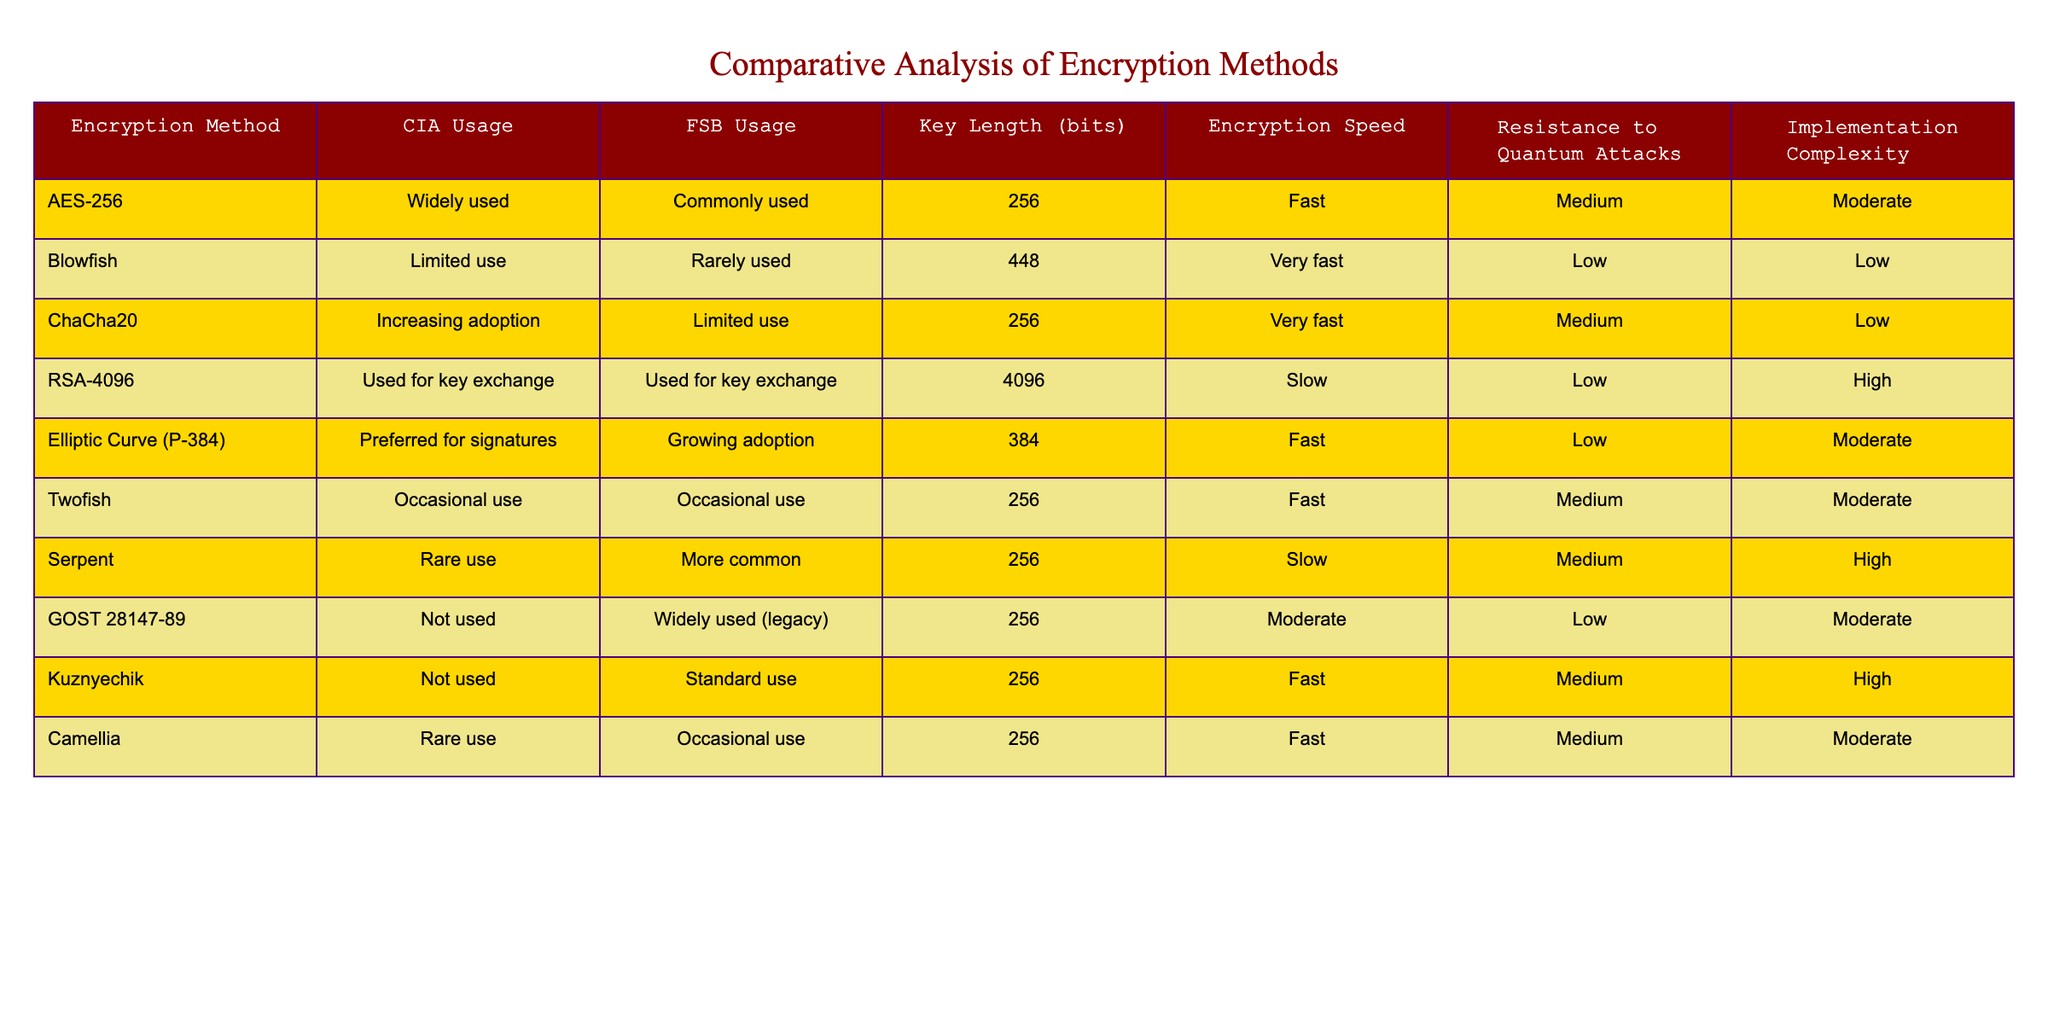What encryption method is widely used by the CIA? The table shows that AES-256 is classified as "Widely used" for CIA usage under Encryption Method.
Answer: AES-256 Which encryption method has the longest key length? By comparing the key lengths listed in the table, RSA-4096 has a key length of 4096 bits, which is the highest among all listed methods.
Answer: RSA-4096 How many encryption methods are rarely used by the CIA? The table lists three encryption methods (Blowfish, Serpent, and Camellia) under the "Rare use" category for CIA usage.
Answer: Three Is AES-256 faster or slower compared to RSA-4096? The table indicates that AES-256 has a "Fast" encryption speed, while RSA-4096 is classified as "Slow," thus showing that AES-256 is faster.
Answer: Faster Which method has higher resistance to quantum attacks, Blowfish or ChaCha20? The resistance to quantum attacks is rated as "Low" for Blowfish and "Medium" for ChaCha20. Therefore, ChaCha20 has higher resistance.
Answer: ChaCha20 What is the average key length of the encryption methods used by the FSB? The key lengths for FSB usage are listed as 256, 256, 256, 384, and 256 (in total of 5 methods). The sum of these key lengths is 256*3 + 384 + 256 = 384 + 768 = 1152, and dividing this by 5 yields an average of 1152/5 = 230.4. So, rounding gives an average of 256 bits.
Answer: 256 bits Does the FSB commonly use the GOST 28147-89 method? Looking at the table, GOST 28147-89 is categorized as "Widely used (legacy)" which indicates it is commonly used by the FSB.
Answer: Yes Which encryption method does the FSB find to be standard? The Kuznyechik encryption method is identified in the table as "Standard use" for the FSB.
Answer: Kuznyechik How many encryption methods are used for key exchange by both CIA and FSB? The table shows that both agencies use RSA-4096 for key exchange, and that is the only method listed for this purpose.
Answer: One Which has a higher implementation complexity: Serpent or Kuznyechik? The table indicates that Serpent has "High" implementation complexity while Kuznyechik has "High" as well, thus they are equally complex.
Answer: Equal complexity 